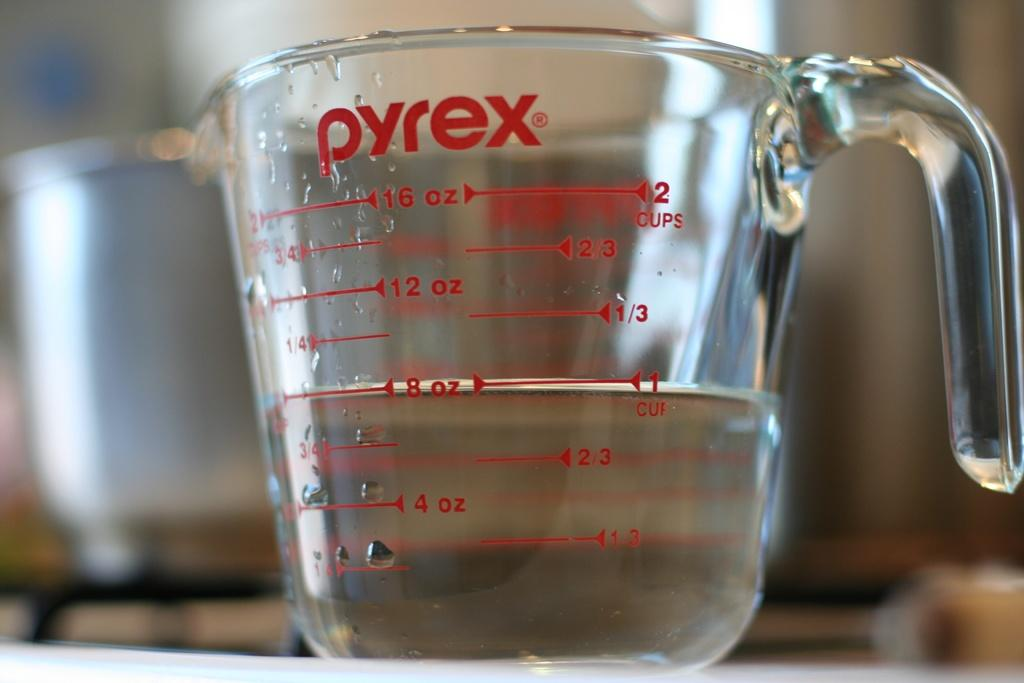<image>
Write a terse but informative summary of the picture. A pyrex measuring cup is filled with a clear liquid to the 8 oz line. 